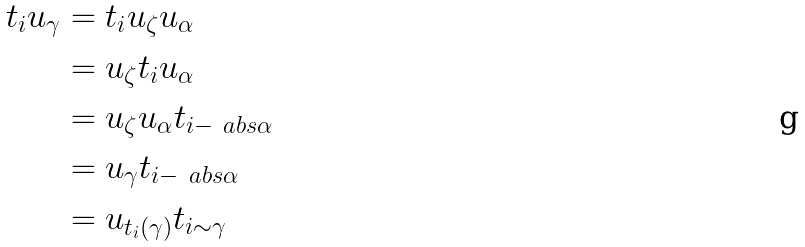Convert formula to latex. <formula><loc_0><loc_0><loc_500><loc_500>t _ { i } u _ { \gamma } & = t _ { i } u _ { \zeta } u _ { \alpha } \\ & = u _ { \zeta } t _ { i } u _ { \alpha } \\ & = u _ { \zeta } u _ { \alpha } t _ { i - \ a b s { \alpha } } \\ & = u _ { \gamma } t _ { i - \ a b s { \alpha } } \\ & = u _ { t _ { i } ( \gamma ) } t _ { i \sim \gamma }</formula> 